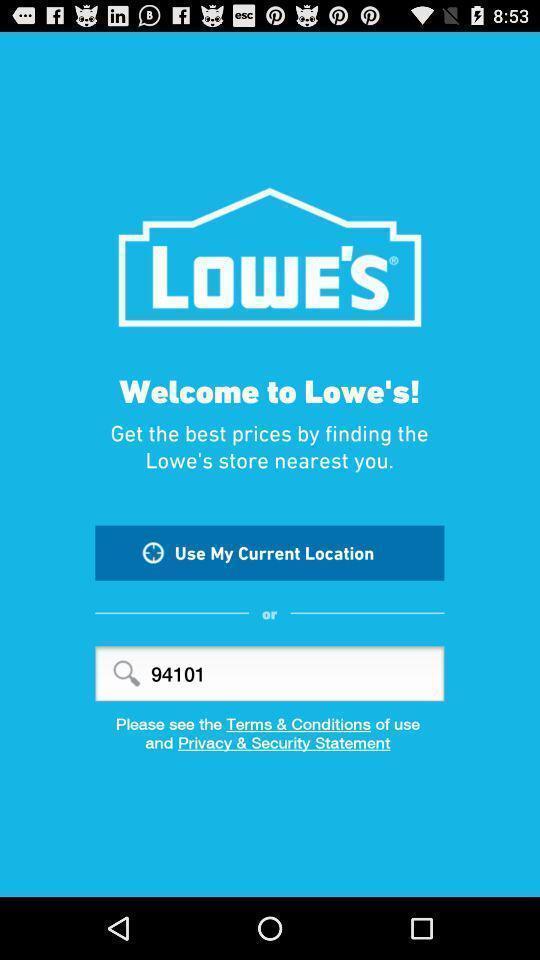Give me a narrative description of this picture. Welcome page. 